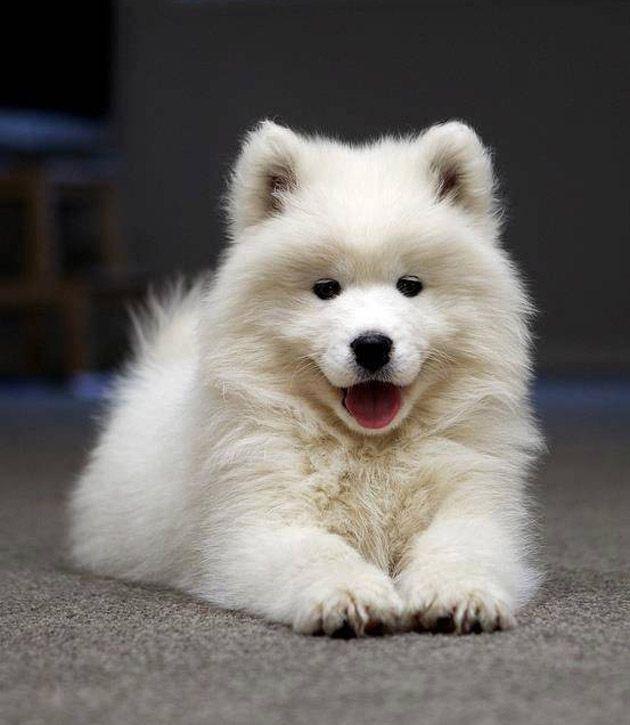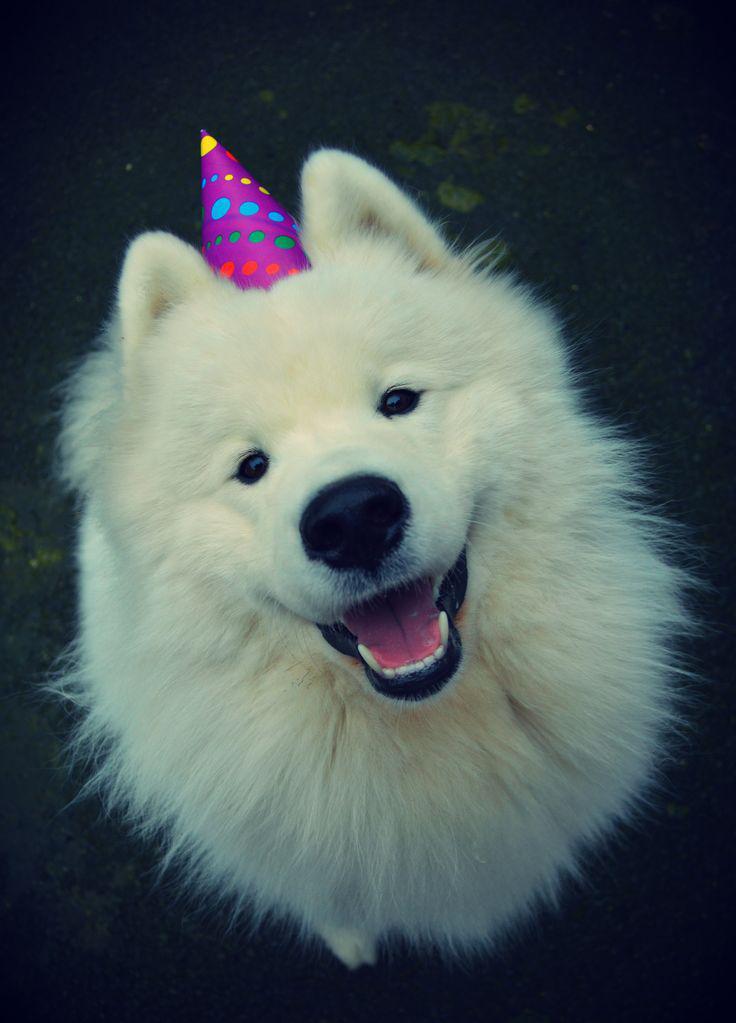The first image is the image on the left, the second image is the image on the right. Considering the images on both sides, is "In the image to the right, all dogs present are adult;they are mature." valid? Answer yes or no. Yes. 